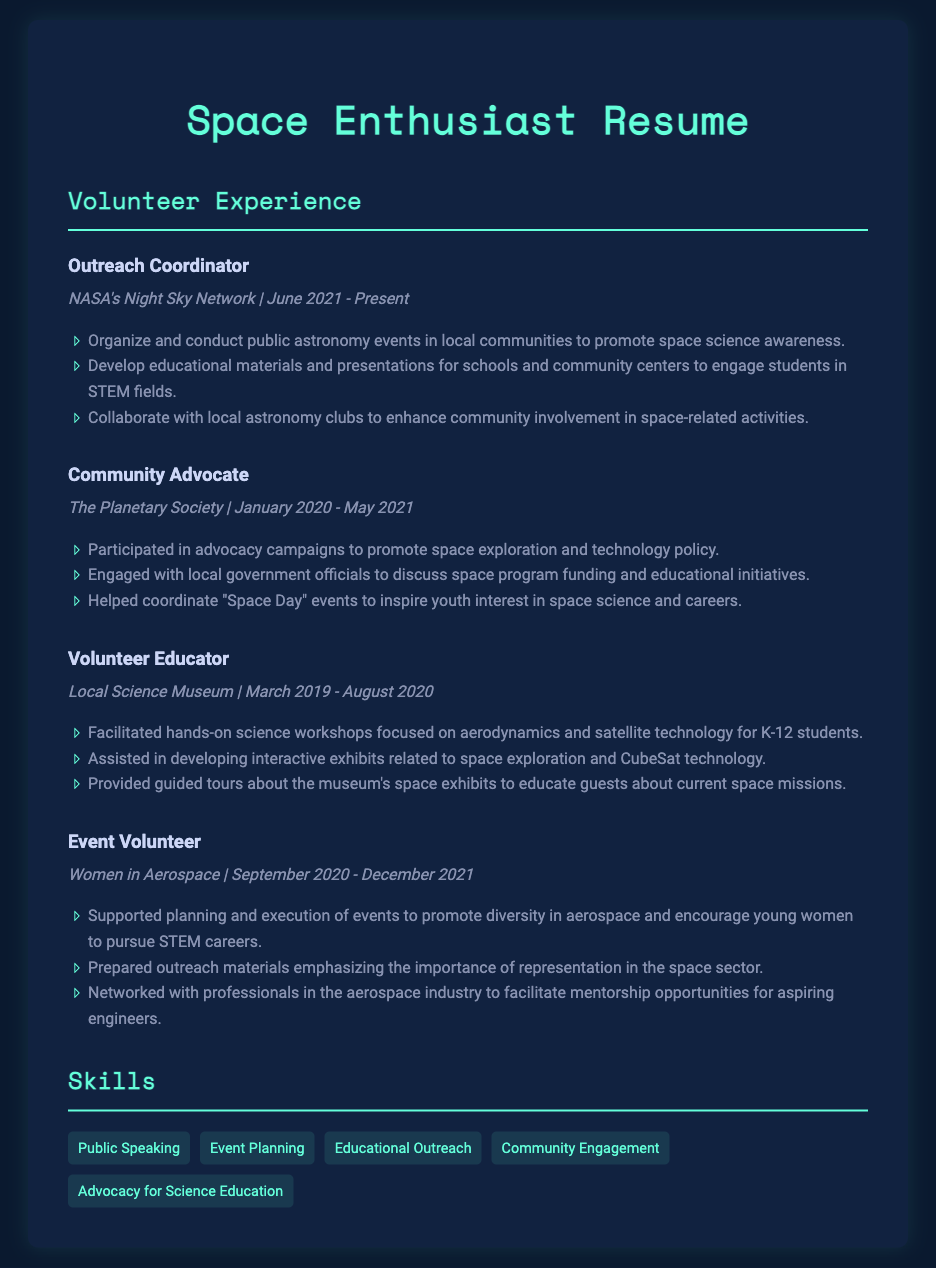What is the title of the document? The title indicates the primary focus or role of the individual, which is reflected in the heading of the resume.
Answer: Space Enthusiast Resume When did the individual volunteer as an Outreach Coordinator? The date range for this volunteer position is specifically mentioned in the document, providing a clear timeframe for the role.
Answer: June 2021 - Present What organization did the individual work with as a Community Advocate? The name of the organization is stated in the experience section, which identifies the group with which the individual collaborated.
Answer: The Planetary Society What type of events did the individual organize as part of their role with NASA's Night Sky Network? This question seeks specific types of activities outlined in the outreach role, highlighting the focus of their community engagement efforts.
Answer: Public astronomy events How many organizations is the individual displayed as engaging with in their volunteer experiences? By counting the distinct organizations mentioned in the volunteer experience section, we derive the total number of organizations involved.
Answer: Four What was a key focus of the Volunteer Educator role? This question requires identifying specific educational efforts made while volunteering, as outlined in the experience section.
Answer: Hands-on science workshops What type of outreach materials did the individual prepare as an Event Volunteer? The content of the outreach materials reflects the individual’s focus on promoting diversity and representation within the space sector.
Answer: Importance of representation in the space sector What skills are highlighted in the Skills section? Identifying the skills listed provides insight into the individual’s abilities and qualifications relevant to their volunteer work.
Answer: Public Speaking, Event Planning, Educational Outreach, Community Engagement, Advocacy for Science Education 